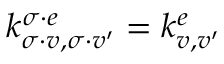Convert formula to latex. <formula><loc_0><loc_0><loc_500><loc_500>k _ { \sigma \cdot v , \sigma \cdot v ^ { \prime } } ^ { \sigma \cdot e } = k _ { v , v ^ { \prime } } ^ { e }</formula> 